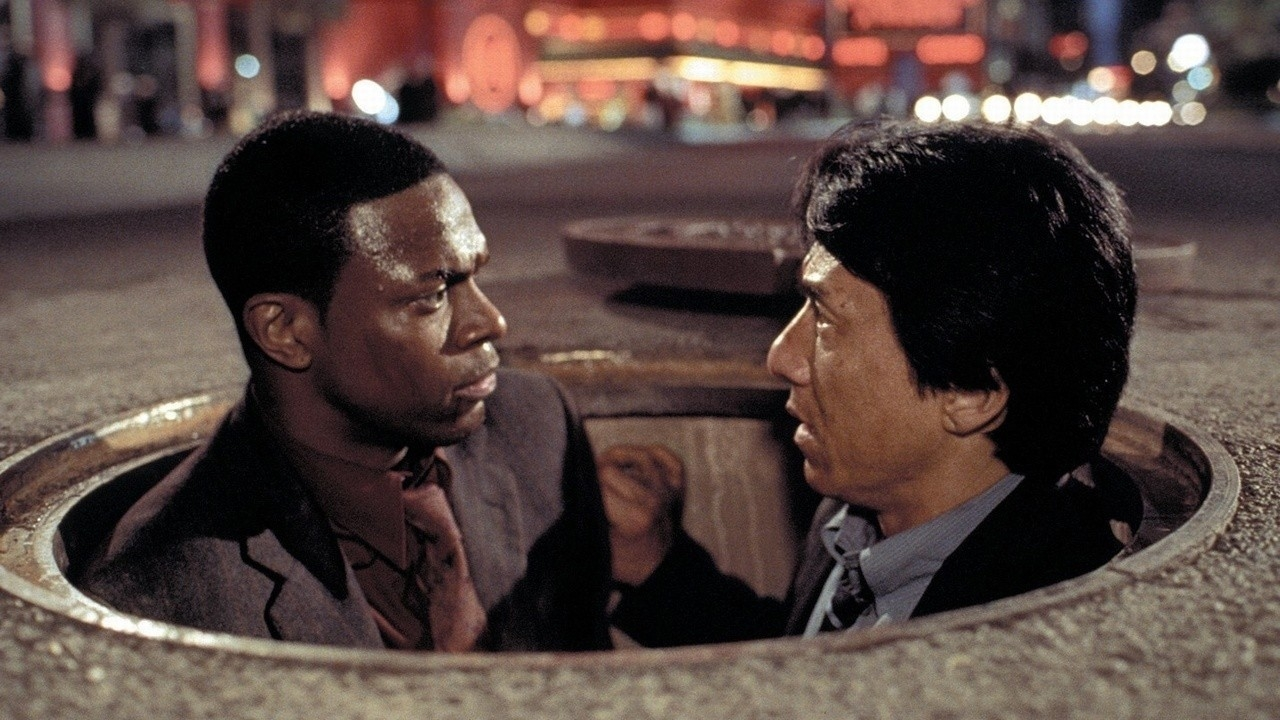What do you think is the context leading up to this scene? In the context of 'Rush Hour 2', this scene likely follows an intense chase or pursuit sequence, where the characters find themselves forced to take refuge in unconventional places, such as a manhole. The serious expressions suggest a moment of tension and urgency, perhaps as they discuss their next move to escape from or thwart their adversaries. 